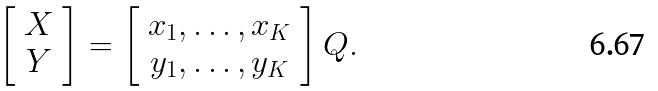Convert formula to latex. <formula><loc_0><loc_0><loc_500><loc_500>\left [ \begin{array} { c } X \\ Y \end{array} \right ] = \left [ \begin{array} { c } x _ { 1 } , \dots , x _ { K } \\ y _ { 1 } , \dots , y _ { K } \end{array} \right ] Q .</formula> 